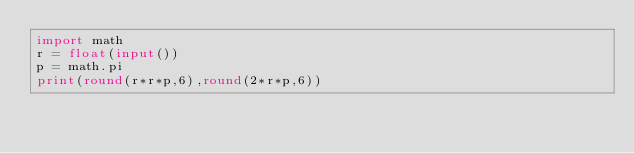Convert code to text. <code><loc_0><loc_0><loc_500><loc_500><_Python_>import math
r = float(input())
p = math.pi
print(round(r*r*p,6),round(2*r*p,6))</code> 